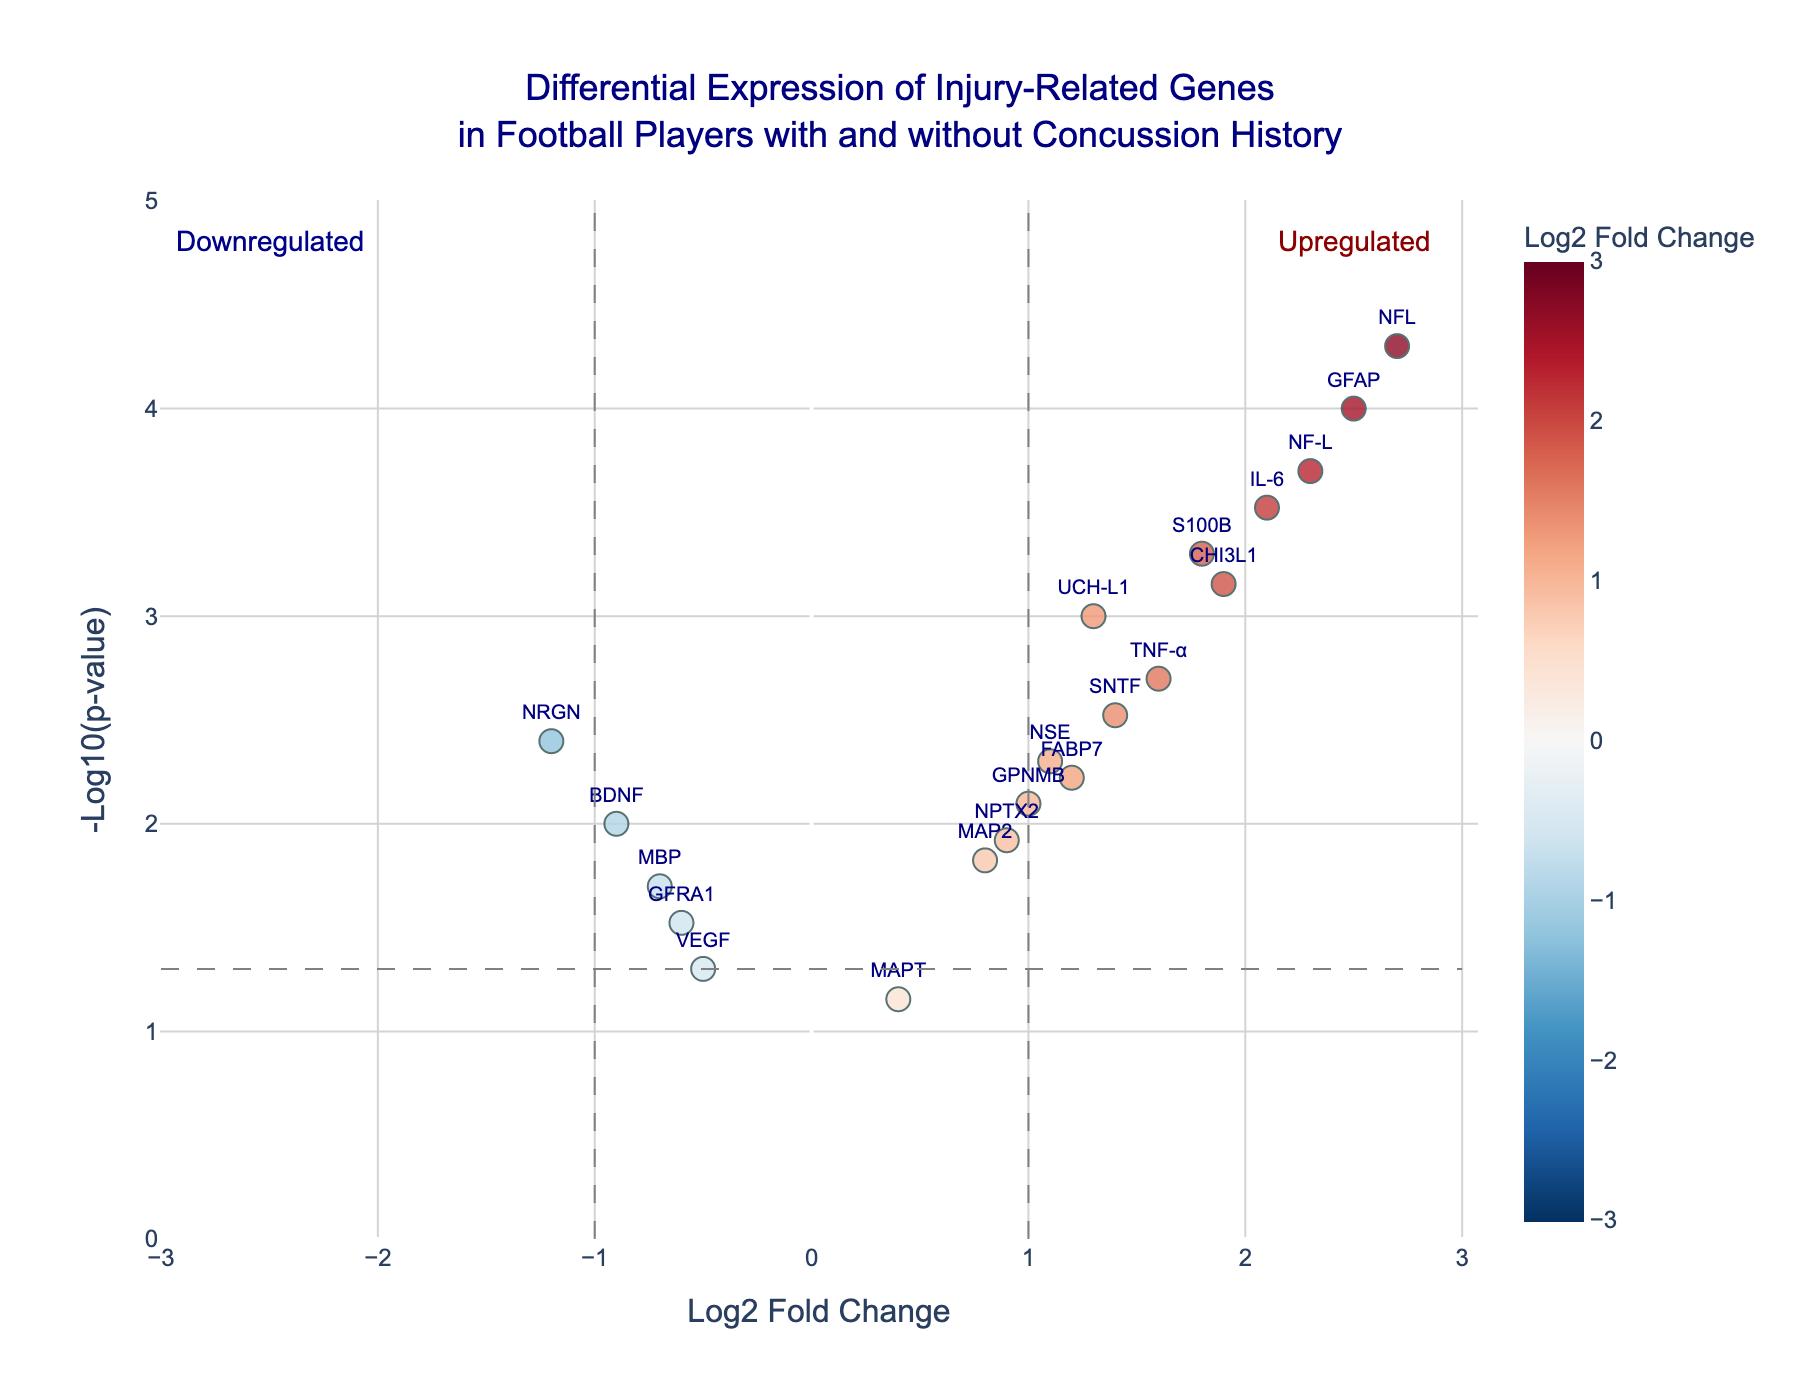What is the title of the plot? The title of the plot is generally located at the top of the figure to provide a brief description of what the figure represents. Here, it says "Differential Expression of Injury-Related Genes in Football Players with and without Concussion History".
Answer: Differential Expression of Injury-Related Genes in Football Players with and without Concussion History What do the x-axis and y-axis represent? The x-axis represents the Log2 Fold Change, indicating the fold change in expression levels of genes, and the y-axis represents the -Log10(p-value), indicating the significance of the changes in gene expression.
Answer: x-axis: Log2 Fold Change, y-axis: -Log10(p-value) Which gene has the highest -log10(p-value) and what is its Log2 Fold Change? From the plot, we can spot the gene farthest up on the y-axis, which represents the highest -log10(p-value). This gene should be identified by its label. The corresponding log2 fold change can be read from the x-axis value.
Answer: NFL, 2.7 How many genes are significantly upregulated? The plot has thresholds at x=1 and y=1.3 for significant fold change and p-value. Genes above y=1.3 and to the right of x=1 are considered significantly upregulated. By counting such points, we can determine the number of significantly upregulated genes.
Answer: 7 Which gene is just at the boundary of being upregulated with a Log2 Fold Change of 1.0? Examining the plot, we identify the gene exactly on the x=1 vertical line, which is the threshold for upregulation. This point should have a Log2 Fold Change of 1.0.
Answer: GPNMB Which gene has the most significant p-value among the downregulated genes? By focusing on the left side of the plot (where the Log2 Fold Change is negative) and identifying the gene that is positioned highest on the y-axis, we can pinpoint the gene with the most significant p-value among the downregulated ones.
Answer: NRGN How many genes have a p-value greater than 0.05? In the plot, points below the y=1.3 line correspond to genes with a p-value greater than 0.05. Counting the points below this line tells us the number of genes that aren't statistically significant.
Answer: 2 Which genes are below the significance threshold but are still upregulated or downregulated? Points below y=1.3 and either to the right of x=1 or to the left of x=-1 represent upregulated or downregulated genes that do not meet the significance threshold. These points can be identified and listed.
Answer: Upregulated: MAPT, Downregulated: VEGF, GFRA1 Which gene has the closest Log2 Fold Change to zero while still being statistically significant? Points closest to the y-axis (Log2 Fold Change near 0) but above the y=1.3 line (statistically significant) must be identified by their coordinates to find the closest one.
Answer: MAP2 What can be inferred about VEGF's significance and regulation? To infer about VEGF, locate this gene on the plot and observe its position relative to the thresholds.
Answer: VEGF is not statistically significant and slightly downregulated 